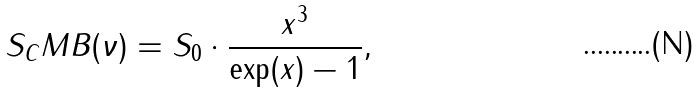<formula> <loc_0><loc_0><loc_500><loc_500>S _ { C } M B ( \nu ) = S _ { 0 } \cdot \frac { x ^ { 3 } } { \exp ( x ) - 1 } ,</formula> 